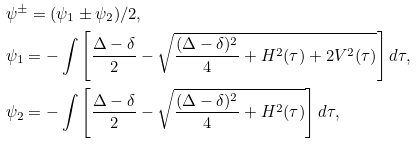<formula> <loc_0><loc_0><loc_500><loc_500>& \psi ^ { \pm } = ( \psi _ { 1 } \pm \psi _ { 2 } ) / 2 , \\ & \psi _ { 1 } = - \int \left [ \frac { \Delta - \delta } { 2 } - \sqrt { \frac { ( \Delta - \delta ) ^ { 2 } } { 4 } + H ^ { 2 } ( \tau ) + 2 V ^ { 2 } ( \tau ) } \right ] d \tau , \\ & \psi _ { 2 } = - \int \left [ \frac { \Delta - \delta } { 2 } - \sqrt { \frac { ( \Delta - \delta ) ^ { 2 } } { 4 } + H ^ { 2 } ( \tau ) } \right ] d \tau ,</formula> 